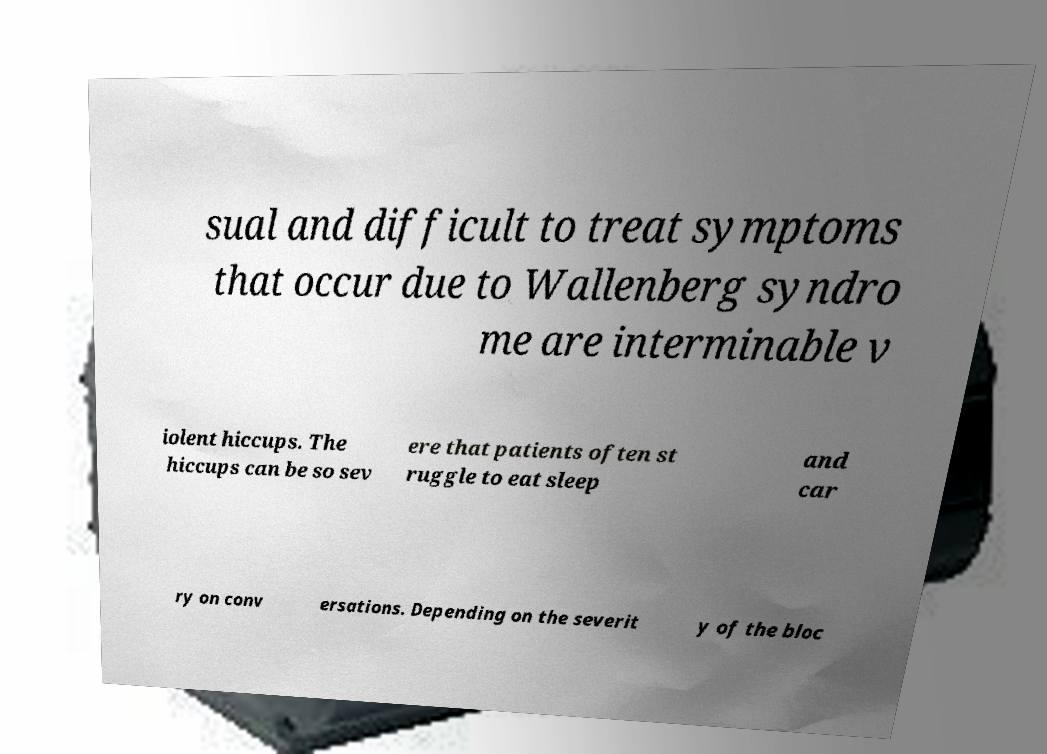Could you assist in decoding the text presented in this image and type it out clearly? sual and difficult to treat symptoms that occur due to Wallenberg syndro me are interminable v iolent hiccups. The hiccups can be so sev ere that patients often st ruggle to eat sleep and car ry on conv ersations. Depending on the severit y of the bloc 